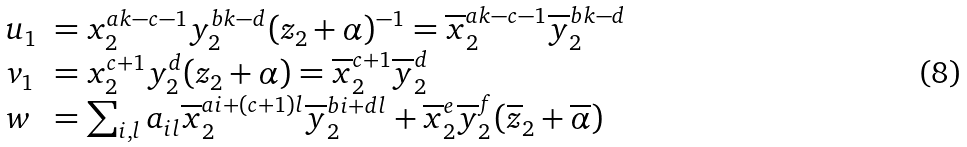Convert formula to latex. <formula><loc_0><loc_0><loc_500><loc_500>\begin{array} { l l } u _ { 1 } & = x _ { 2 } ^ { a k - c - 1 } y _ { 2 } ^ { b k - d } ( z _ { 2 } + \alpha ) ^ { - 1 } = \overline { x } _ { 2 } ^ { a k - c - 1 } \overline { y } _ { 2 } ^ { b k - d } \\ v _ { 1 } & = x _ { 2 } ^ { c + 1 } y _ { 2 } ^ { d } ( z _ { 2 } + \alpha ) = \overline { x } _ { 2 } ^ { c + 1 } \overline { y } _ { 2 } ^ { d } \\ w & = \sum _ { i , l } a _ { i l } \overline { x } _ { 2 } ^ { a i + ( c + 1 ) l } \overline { y } _ { 2 } ^ { b i + d l } + \overline { x } _ { 2 } ^ { e } \overline { y } _ { 2 } ^ { f } ( \overline { z } _ { 2 } + \overline { \alpha } ) \end{array}</formula> 